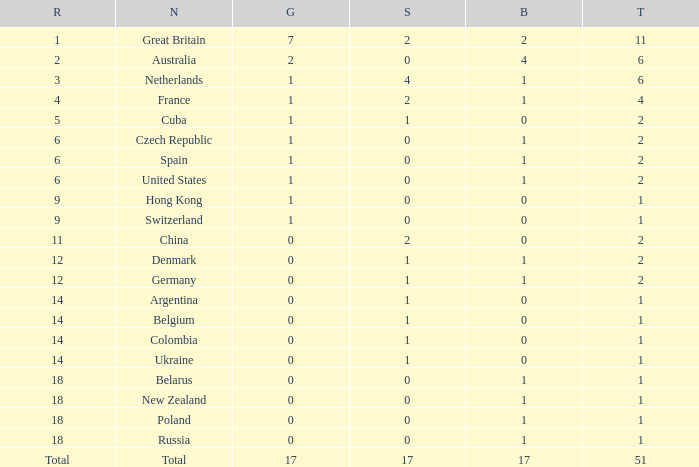Tell me the rank for bronze less than 17 and gold less than 1 11.0. 